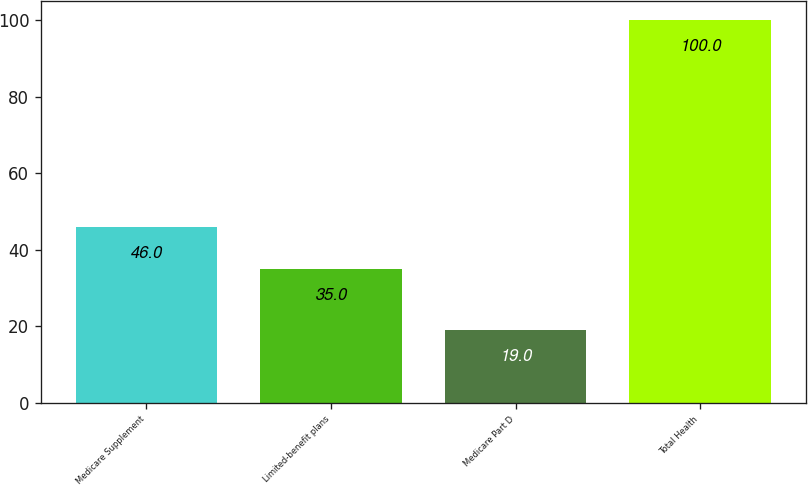Convert chart to OTSL. <chart><loc_0><loc_0><loc_500><loc_500><bar_chart><fcel>Medicare Supplement<fcel>Limited-benefit plans<fcel>Medicare Part D<fcel>Total Health<nl><fcel>46<fcel>35<fcel>19<fcel>100<nl></chart> 